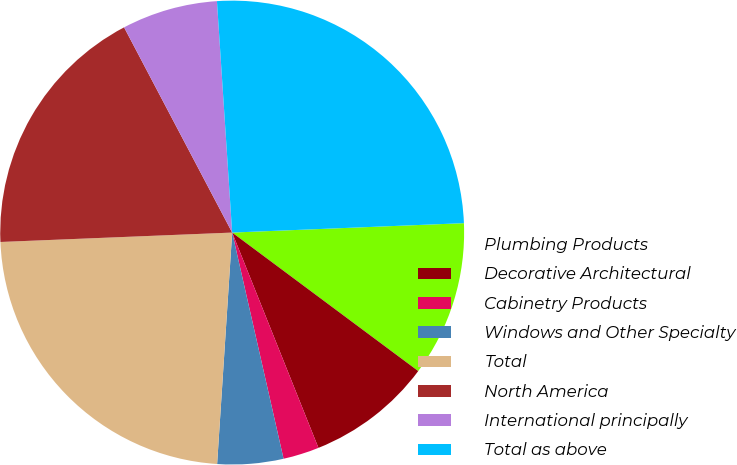<chart> <loc_0><loc_0><loc_500><loc_500><pie_chart><fcel>Plumbing Products<fcel>Decorative Architectural<fcel>Cabinetry Products<fcel>Windows and Other Specialty<fcel>Total<fcel>North America<fcel>International principally<fcel>Total as above<nl><fcel>10.83%<fcel>8.75%<fcel>2.51%<fcel>4.59%<fcel>23.32%<fcel>17.93%<fcel>6.67%<fcel>25.4%<nl></chart> 